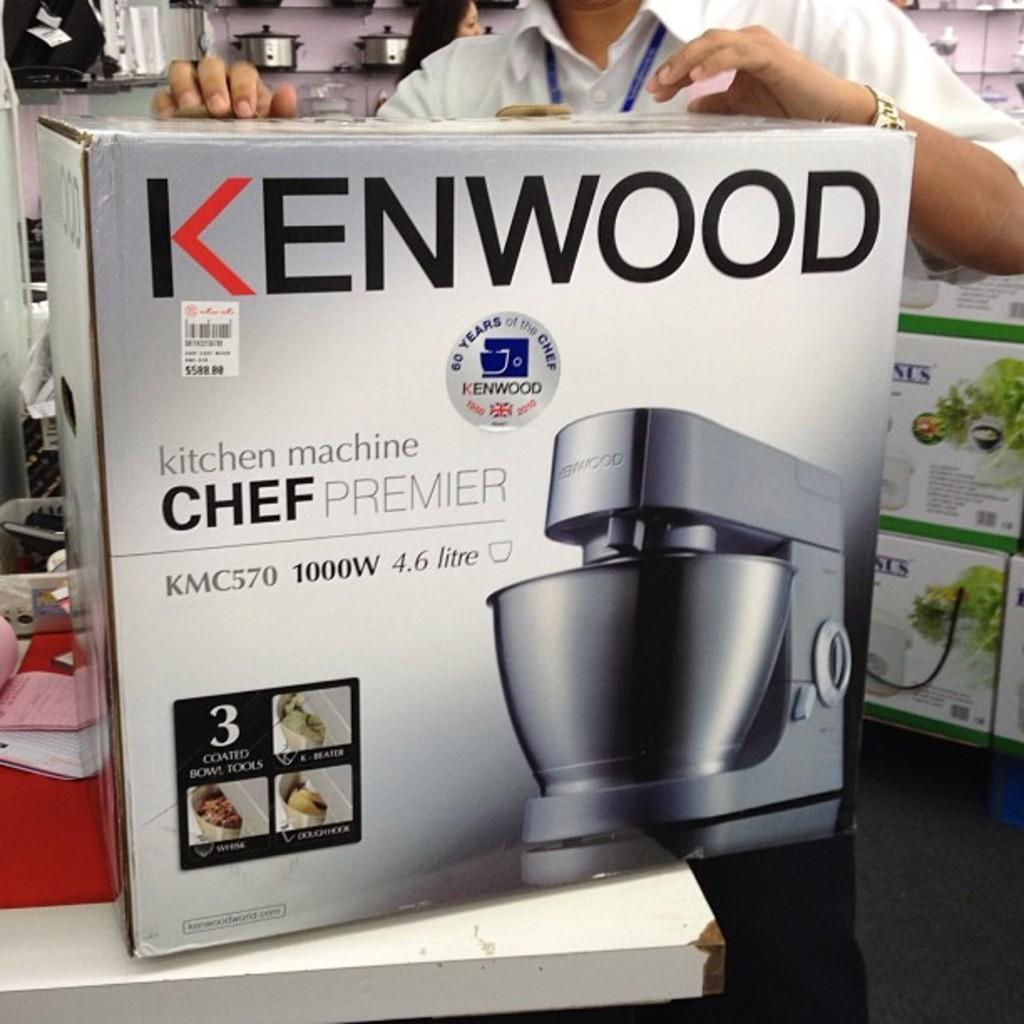<image>
Give a short and clear explanation of the subsequent image. A Kenwood chef premier mixer is proudly displayed. 